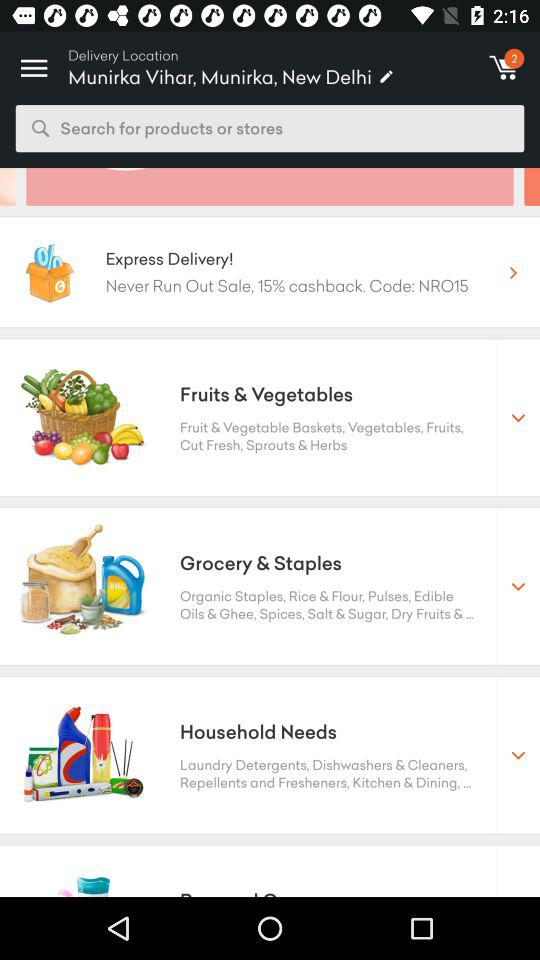What is the location of delivery? The location of delivery is "Munirka Vihar, Munirka, New Delhi". 